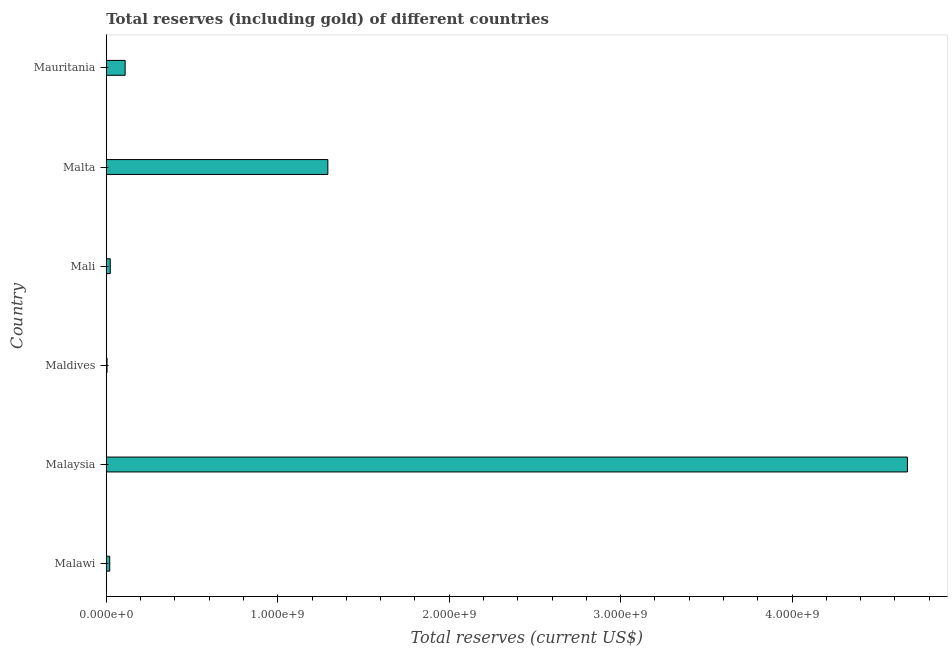Does the graph contain any zero values?
Provide a succinct answer. No. What is the title of the graph?
Provide a short and direct response. Total reserves (including gold) of different countries. What is the label or title of the X-axis?
Provide a succinct answer. Total reserves (current US$). What is the total reserves (including gold) in Malawi?
Your response must be concise. 2.03e+07. Across all countries, what is the maximum total reserves (including gold)?
Offer a terse response. 4.67e+09. Across all countries, what is the minimum total reserves (including gold)?
Offer a very short reply. 4.54e+06. In which country was the total reserves (including gold) maximum?
Your response must be concise. Malaysia. In which country was the total reserves (including gold) minimum?
Your response must be concise. Maldives. What is the sum of the total reserves (including gold)?
Your response must be concise. 6.12e+09. What is the difference between the total reserves (including gold) in Maldives and Mali?
Provide a succinct answer. -1.89e+07. What is the average total reserves (including gold) per country?
Offer a very short reply. 1.02e+09. What is the median total reserves (including gold)?
Offer a very short reply. 6.68e+07. What is the ratio of the total reserves (including gold) in Malawi to that in Mali?
Your response must be concise. 0.87. Is the difference between the total reserves (including gold) in Maldives and Mali greater than the difference between any two countries?
Your answer should be compact. No. What is the difference between the highest and the second highest total reserves (including gold)?
Provide a short and direct response. 3.38e+09. What is the difference between the highest and the lowest total reserves (including gold)?
Keep it short and to the point. 4.67e+09. How many bars are there?
Offer a terse response. 6. What is the difference between two consecutive major ticks on the X-axis?
Your answer should be compact. 1.00e+09. What is the Total reserves (current US$) of Malawi?
Offer a terse response. 2.03e+07. What is the Total reserves (current US$) in Malaysia?
Offer a terse response. 4.67e+09. What is the Total reserves (current US$) in Maldives?
Your answer should be very brief. 4.54e+06. What is the Total reserves (current US$) of Mali?
Your answer should be very brief. 2.34e+07. What is the Total reserves (current US$) in Malta?
Provide a short and direct response. 1.29e+09. What is the Total reserves (current US$) of Mauritania?
Offer a terse response. 1.10e+08. What is the difference between the Total reserves (current US$) in Malawi and Malaysia?
Provide a succinct answer. -4.65e+09. What is the difference between the Total reserves (current US$) in Malawi and Maldives?
Offer a terse response. 1.58e+07. What is the difference between the Total reserves (current US$) in Malawi and Mali?
Your response must be concise. -3.12e+06. What is the difference between the Total reserves (current US$) in Malawi and Malta?
Your answer should be very brief. -1.27e+09. What is the difference between the Total reserves (current US$) in Malawi and Mauritania?
Provide a short and direct response. -8.99e+07. What is the difference between the Total reserves (current US$) in Malaysia and Maldives?
Make the answer very short. 4.67e+09. What is the difference between the Total reserves (current US$) in Malaysia and Mali?
Your response must be concise. 4.65e+09. What is the difference between the Total reserves (current US$) in Malaysia and Malta?
Make the answer very short. 3.38e+09. What is the difference between the Total reserves (current US$) in Malaysia and Mauritania?
Your answer should be compact. 4.56e+09. What is the difference between the Total reserves (current US$) in Maldives and Mali?
Make the answer very short. -1.89e+07. What is the difference between the Total reserves (current US$) in Maldives and Malta?
Your answer should be compact. -1.29e+09. What is the difference between the Total reserves (current US$) in Maldives and Mauritania?
Give a very brief answer. -1.06e+08. What is the difference between the Total reserves (current US$) in Mali and Malta?
Ensure brevity in your answer.  -1.27e+09. What is the difference between the Total reserves (current US$) in Mali and Mauritania?
Ensure brevity in your answer.  -8.68e+07. What is the difference between the Total reserves (current US$) in Malta and Mauritania?
Offer a very short reply. 1.18e+09. What is the ratio of the Total reserves (current US$) in Malawi to that in Malaysia?
Keep it short and to the point. 0. What is the ratio of the Total reserves (current US$) in Malawi to that in Maldives?
Offer a terse response. 4.47. What is the ratio of the Total reserves (current US$) in Malawi to that in Mali?
Offer a terse response. 0.87. What is the ratio of the Total reserves (current US$) in Malawi to that in Malta?
Make the answer very short. 0.02. What is the ratio of the Total reserves (current US$) in Malawi to that in Mauritania?
Your answer should be compact. 0.18. What is the ratio of the Total reserves (current US$) in Malaysia to that in Maldives?
Provide a short and direct response. 1028.95. What is the ratio of the Total reserves (current US$) in Malaysia to that in Mali?
Ensure brevity in your answer.  199.55. What is the ratio of the Total reserves (current US$) in Malaysia to that in Malta?
Give a very brief answer. 3.62. What is the ratio of the Total reserves (current US$) in Malaysia to that in Mauritania?
Provide a succinct answer. 42.41. What is the ratio of the Total reserves (current US$) in Maldives to that in Mali?
Ensure brevity in your answer.  0.19. What is the ratio of the Total reserves (current US$) in Maldives to that in Malta?
Provide a short and direct response. 0. What is the ratio of the Total reserves (current US$) in Maldives to that in Mauritania?
Offer a terse response. 0.04. What is the ratio of the Total reserves (current US$) in Mali to that in Malta?
Provide a short and direct response. 0.02. What is the ratio of the Total reserves (current US$) in Mali to that in Mauritania?
Provide a succinct answer. 0.21. What is the ratio of the Total reserves (current US$) in Malta to that in Mauritania?
Provide a succinct answer. 11.73. 